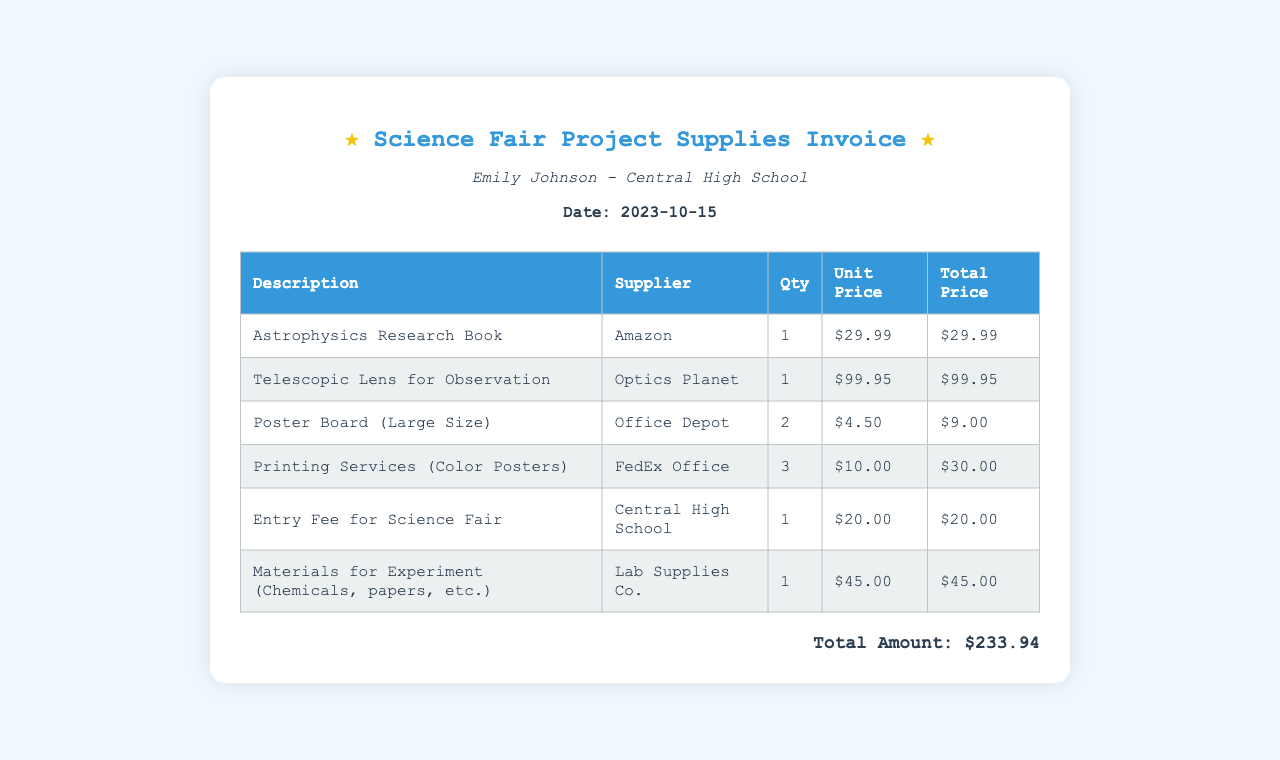What is the date of the invoice? The date mentioned in the invoice is 2023-10-15, which indicates when the invoice was created.
Answer: 2023-10-15 Who is the student on this invoice? The invoice states that the student is Emily Johnson, indicating her identity as the requester of the supplies.
Answer: Emily Johnson How many telescopic lenses were purchased? The invoice lists the quantity of telescopic lenses purchased as 1, showing the number of units obtained.
Answer: 1 What is the total amount of the invoice? The total amount is calculated from the sums of all the items listed in the invoice, which totals to $233.94.
Answer: $233.94 What is the entry fee for the science fair? The invoice specifies the entry fee charged for participating in the science fair as $20.00.
Answer: $20.00 How many posters were printed in color? The invoice indicates that 3 color posters were printed, which is relevant for understanding the printing services used.
Answer: 3 Which company supplied the materials for the experiment? The invoice reveals that the materials for the experiment were provided by Lab Supplies Co.
Answer: Lab Supplies Co What is the unit price of the Astrophysics Research Book? The unit price displayed for the Astrophysics Research Book is $29.99, which shows its individual cost.
Answer: $29.99 What is the total quantity of poster boards purchased? The invoice shows that 2 large-sized poster boards were bought, reflecting the amount needed for the project.
Answer: 2 